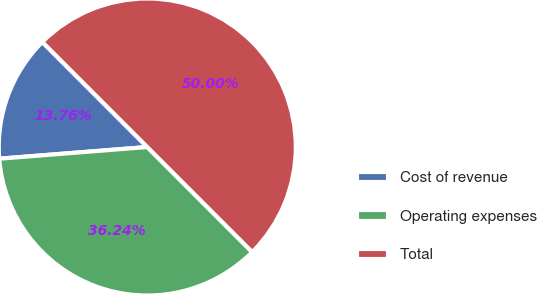<chart> <loc_0><loc_0><loc_500><loc_500><pie_chart><fcel>Cost of revenue<fcel>Operating expenses<fcel>Total<nl><fcel>13.76%<fcel>36.24%<fcel>50.0%<nl></chart> 